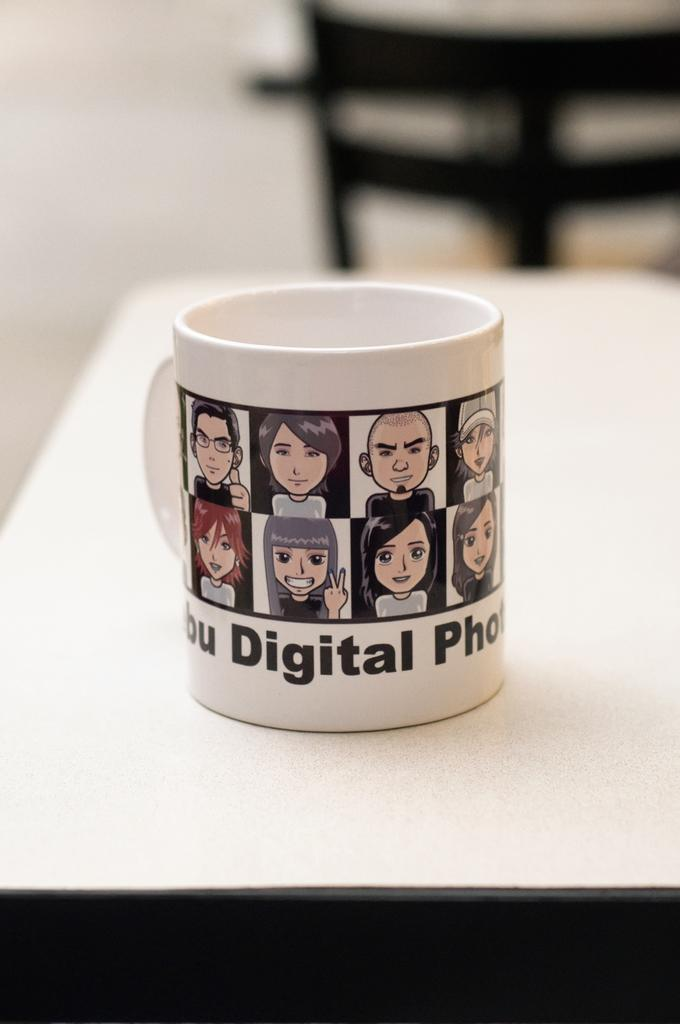<image>
Write a terse but informative summary of the picture. The word digital is on the side of a mug covered in avatars of people. 